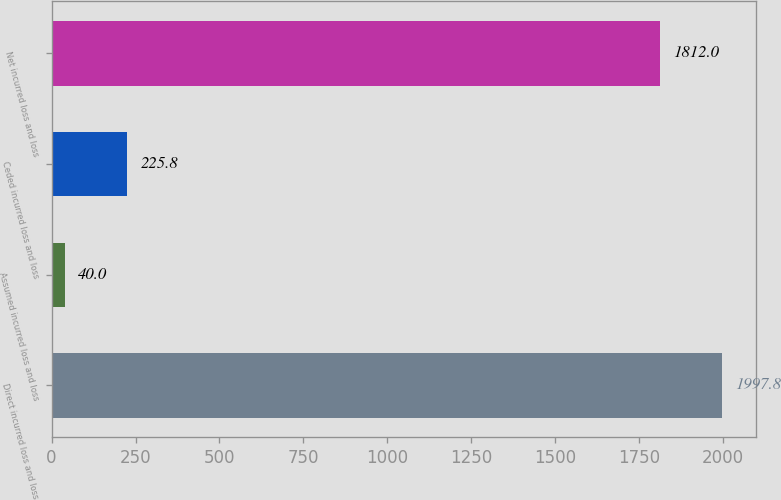Convert chart. <chart><loc_0><loc_0><loc_500><loc_500><bar_chart><fcel>Direct incurred loss and loss<fcel>Assumed incurred loss and loss<fcel>Ceded incurred loss and loss<fcel>Net incurred loss and loss<nl><fcel>1997.8<fcel>40<fcel>225.8<fcel>1812<nl></chart> 